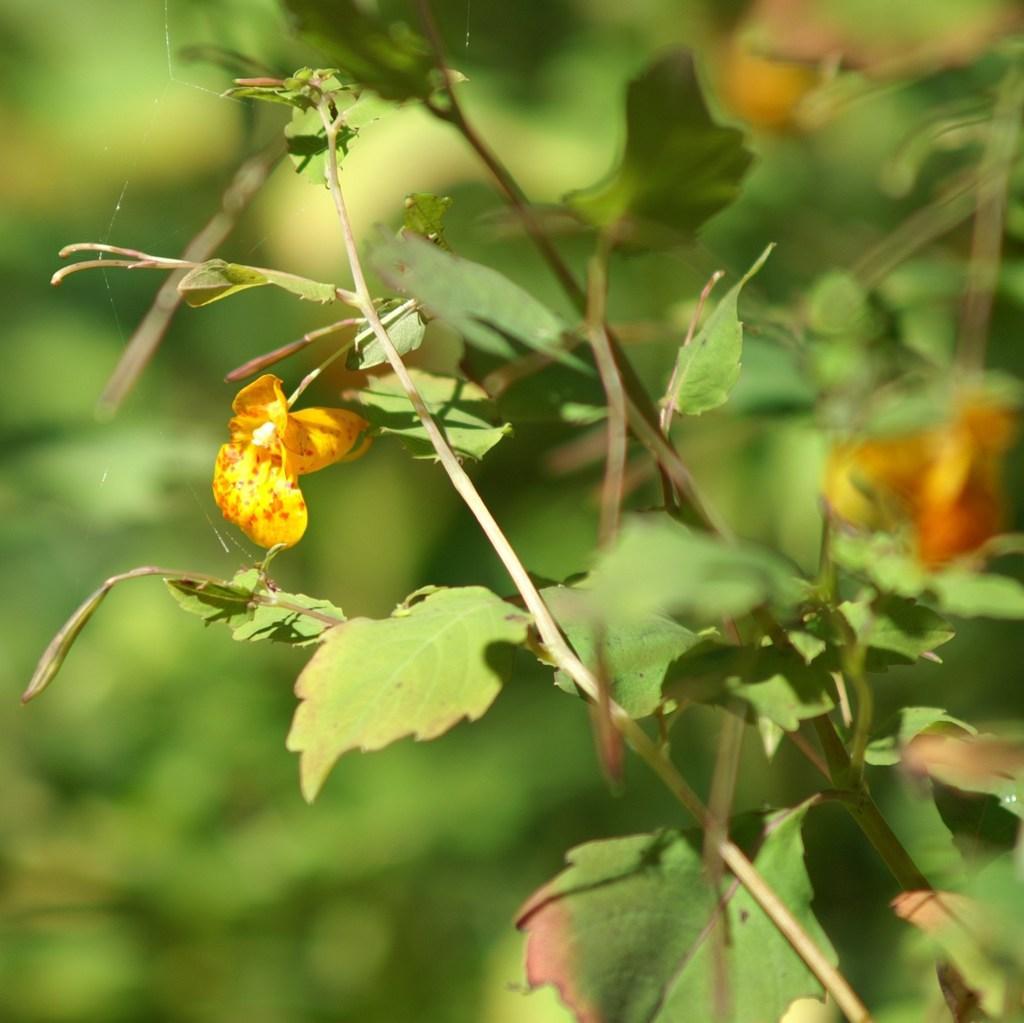Please provide a concise description of this image. In this picture we can see few flowers and plants. 